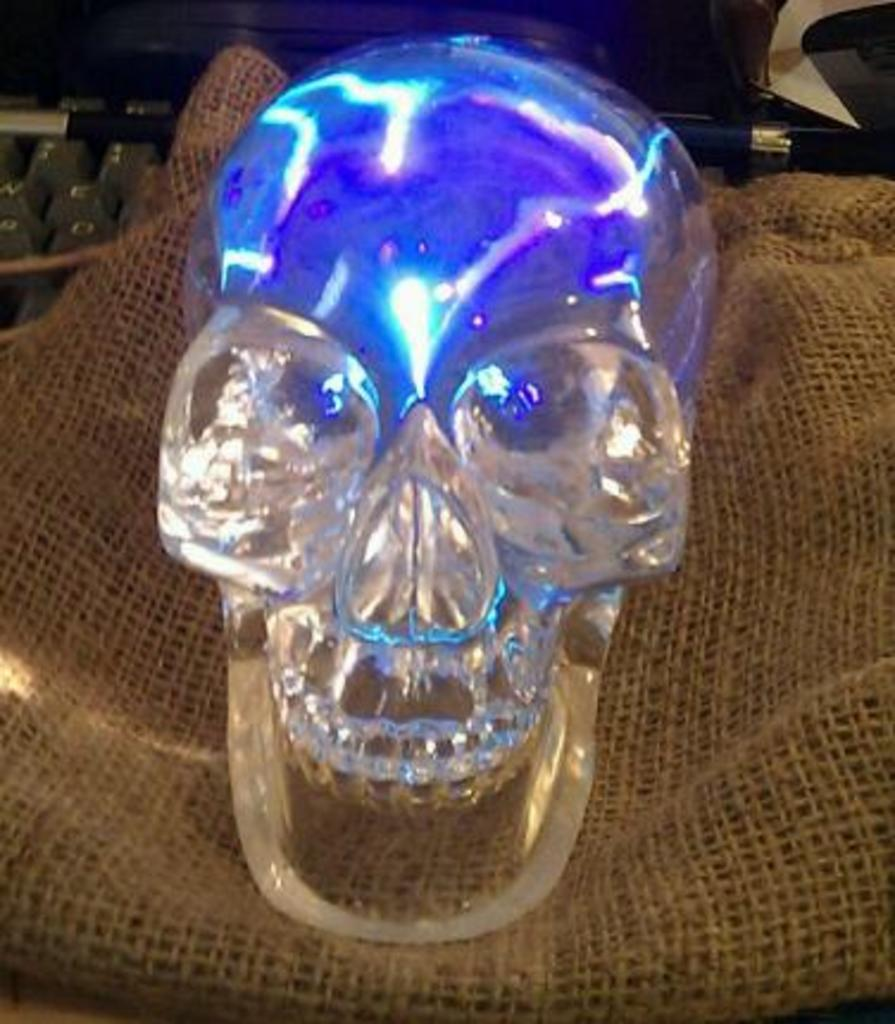What is the main subject of the image? The main subject of the image is a skull. What other object can be seen in the image? There is a jute bag in the image. What type of land can be seen in the image? There is no land visible in the image; it only features a skull and a jute bag. 